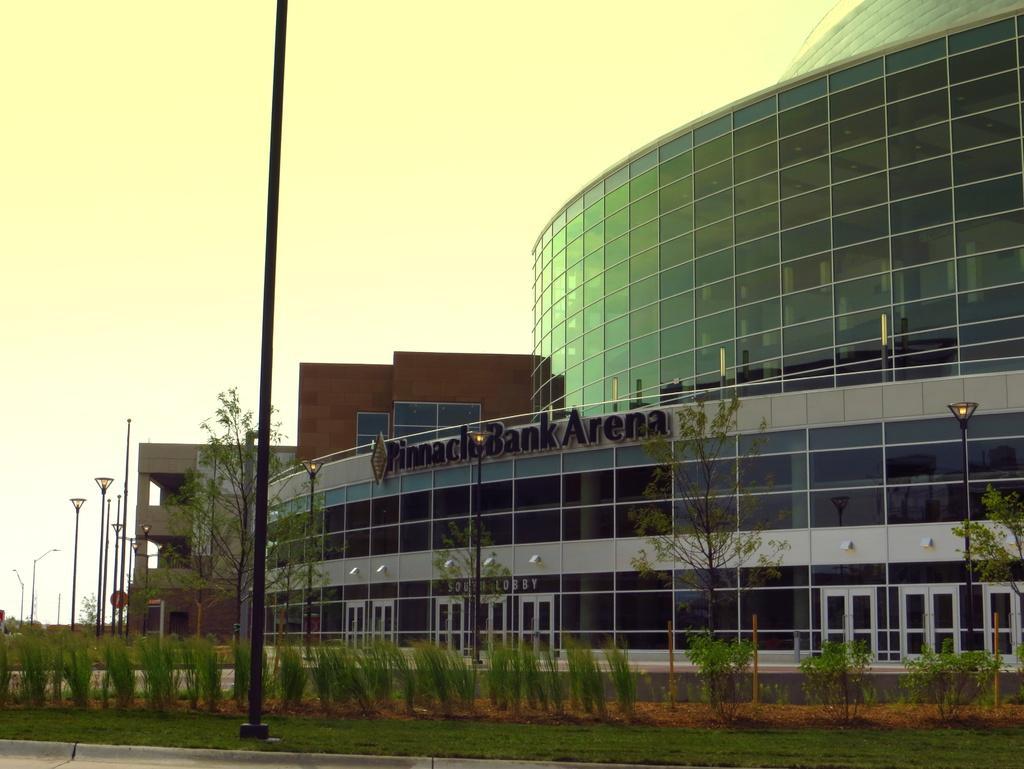How would you summarize this image in a sentence or two? In this picture we can see the buildings, doors, poles, lights, trees. At the top of the image we can see the sky. At the bottom of the image we can see the plants, grass and road. In the middle of the image we can see some text is present on the wall. 